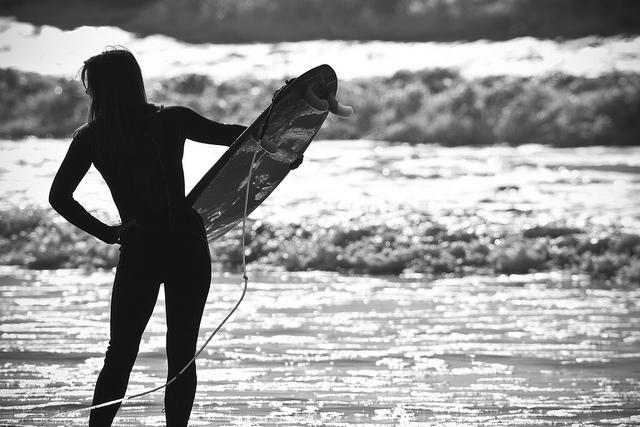Is the surfboard in the water?
Give a very brief answer. No. Is there a storm on the horizon?
Give a very brief answer. No. Is the water calm?
Concise answer only. No. 